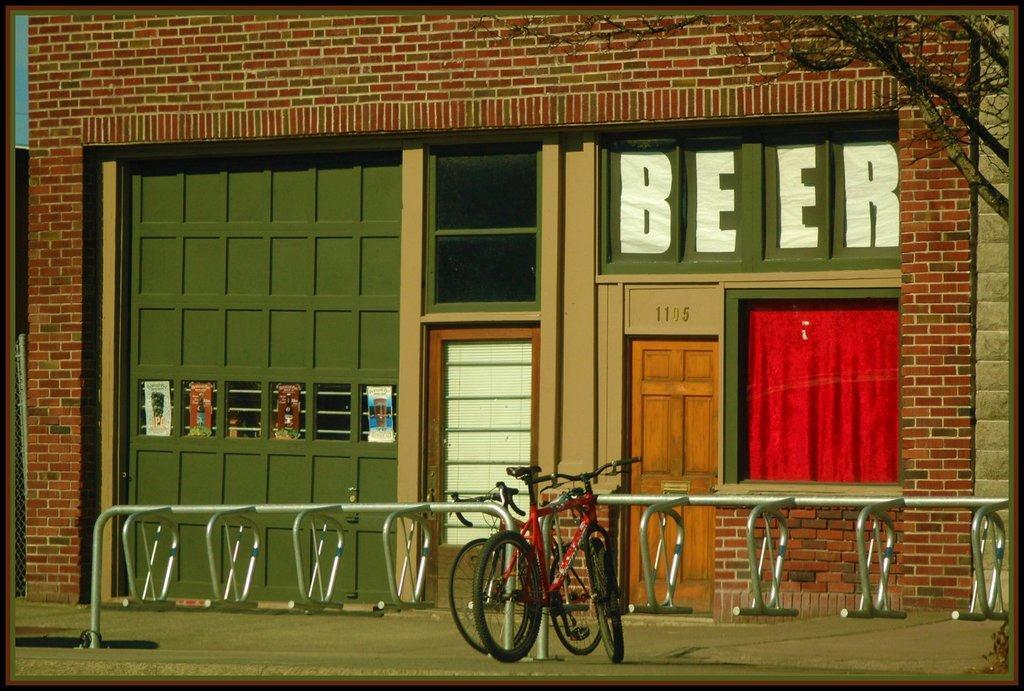Please provide a concise description of this image. This is an edited image. In this image, I can see a building along with the doors and windows. On the right side there is a red color curtain to the window. In front of this building there is a railing and there are two bicycles. In the top right-hand corner there is a tree. 